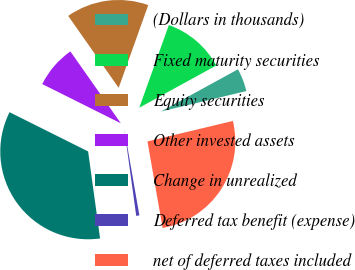<chart> <loc_0><loc_0><loc_500><loc_500><pie_chart><fcel>(Dollars in thousands)<fcel>Fixed maturity securities<fcel>Equity securities<fcel>Other invested assets<fcel>Change in unrealized<fcel>Deferred tax benefit (expense)<fcel>net of deferred taxes included<nl><fcel>4.24%<fcel>11.55%<fcel>15.21%<fcel>7.89%<fcel>34.55%<fcel>0.58%<fcel>25.99%<nl></chart> 